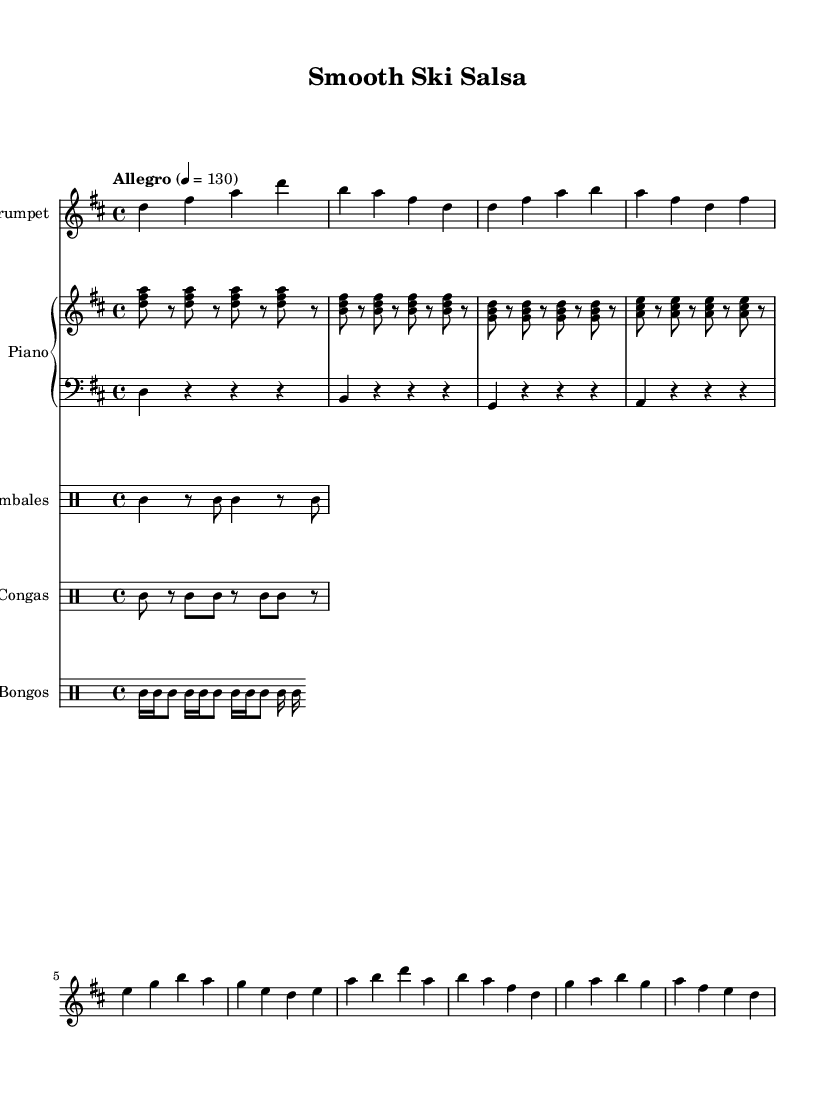what is the key signature of this music? The key signature is indicated by the sharp symbol next to the staff. The layout shows two sharps (F# and C#) which indicates that it is in D major.
Answer: D major what is the time signature of the piece? The time signature is indicated at the beginning of the staff. It shows a "4" on top of another "4," meaning there are four beats in each measure.
Answer: 4/4 what is the tempo marking of this music? The tempo marking is found at the beginning and is labeled "Allegro" with a metrically defined number of 130 beats per minute.
Answer: Allegro, 130 how many measures are in the trumpet part? To find the number of measures, count the groups of vertical lines (bars) in the trumpet part. Each group represents a measure. There are 8 measures in total.
Answer: 8 what rhythmic instrument is paired with the trumpet in the drum section? The sheet music shows separate staff lines for various drums. The timbales are the first listed and are paired with the trumpet, providing a distinctive rhythm.
Answer: Timbales what type of pattern is used in the piano part? The piano part shows a repeated montuno pattern, which is typical for Latin music, consisting of rhythmic chords played in a syncopated manner.
Answer: Montuno pattern how many different drumming instruments are listed in the score? Count the distinct drum staffs in the score. There are three drum types: Timbales, Congas, and Bongos, each shown on separate staffs.
Answer: Three 